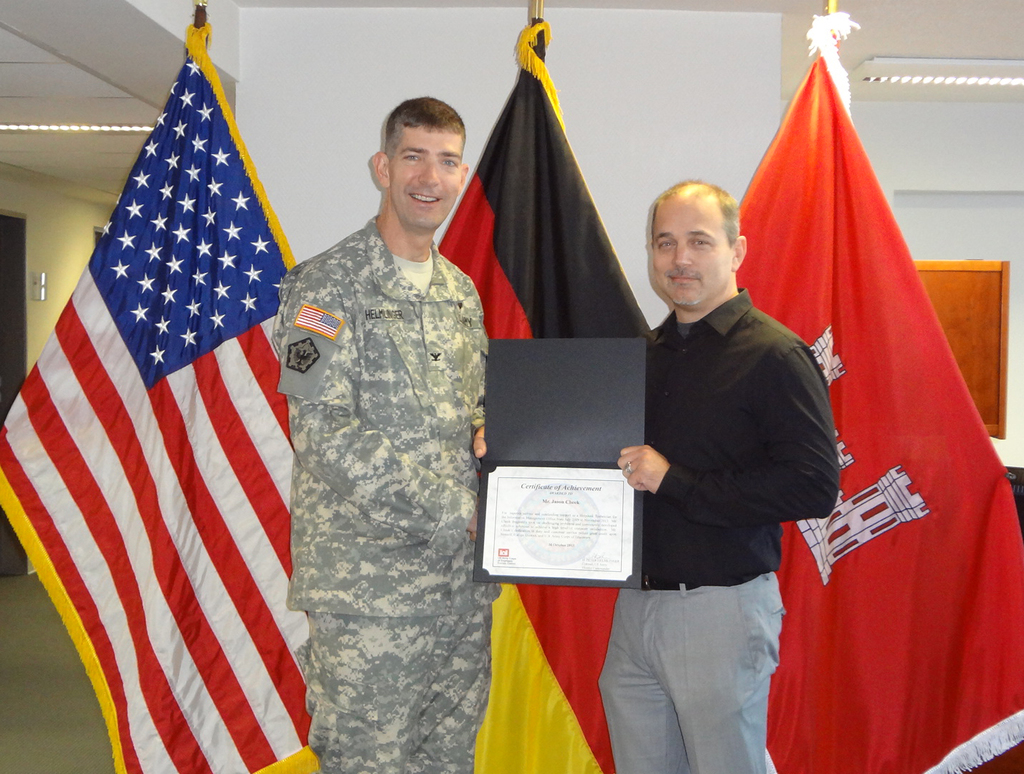Provide a one-sentence caption for the provided image. A military officer in uniform proudly receives a certificate from a civilian, surrounded by the American and German flags, symbolizing a moment of cross-cultural appreciation and achievement. 